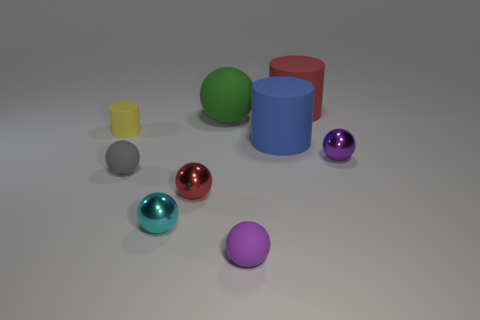Subtract all large red rubber cylinders. How many cylinders are left? 2 Add 1 small red rubber things. How many objects exist? 10 Subtract all cylinders. How many objects are left? 6 Subtract 1 spheres. How many spheres are left? 5 Subtract all brown spheres. Subtract all green cubes. How many spheres are left? 6 Subtract all purple balls. How many yellow cylinders are left? 1 Subtract all big red rubber things. Subtract all tiny yellow cylinders. How many objects are left? 7 Add 5 small red shiny spheres. How many small red shiny spheres are left? 6 Add 6 gray matte spheres. How many gray matte spheres exist? 7 Subtract all red balls. How many balls are left? 5 